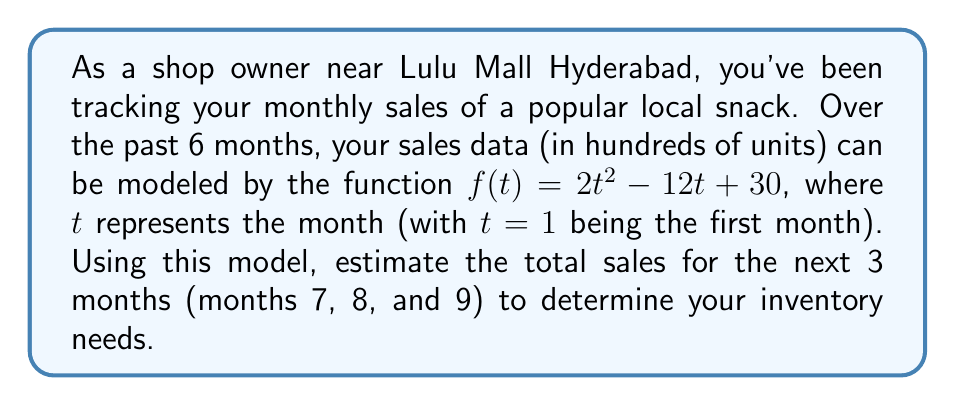Show me your answer to this math problem. To solve this problem, we need to follow these steps:

1) The sales function is given as $f(t) = 2t^2 - 12t + 30$, where $t$ represents the month.

2) We need to calculate the sales for months 7, 8, and 9. Let's do this one by one:

   For month 7 ($t=7$):
   $f(7) = 2(7^2) - 12(7) + 30$
         $= 2(49) - 84 + 30$
         $= 98 - 84 + 30$
         $= 44$ hundred units or 4,400 units

   For month 8 ($t=8$):
   $f(8) = 2(8^2) - 12(8) + 30$
         $= 2(64) - 96 + 30$
         $= 128 - 96 + 30$
         $= 62$ hundred units or 6,200 units

   For month 9 ($t=9$):
   $f(9) = 2(9^2) - 12(9) + 30$
         $= 2(81) - 108 + 30$
         $= 162 - 108 + 30$
         $= 84$ hundred units or 8,400 units

3) Now, we need to sum up these values to get the total sales for the next 3 months:

   Total sales = 4,400 + 6,200 + 8,400 = 19,000 units

Therefore, based on this forecast model, you should prepare inventory for approximately 19,000 units of the snack for the next 3 months.
Answer: 19,000 units 